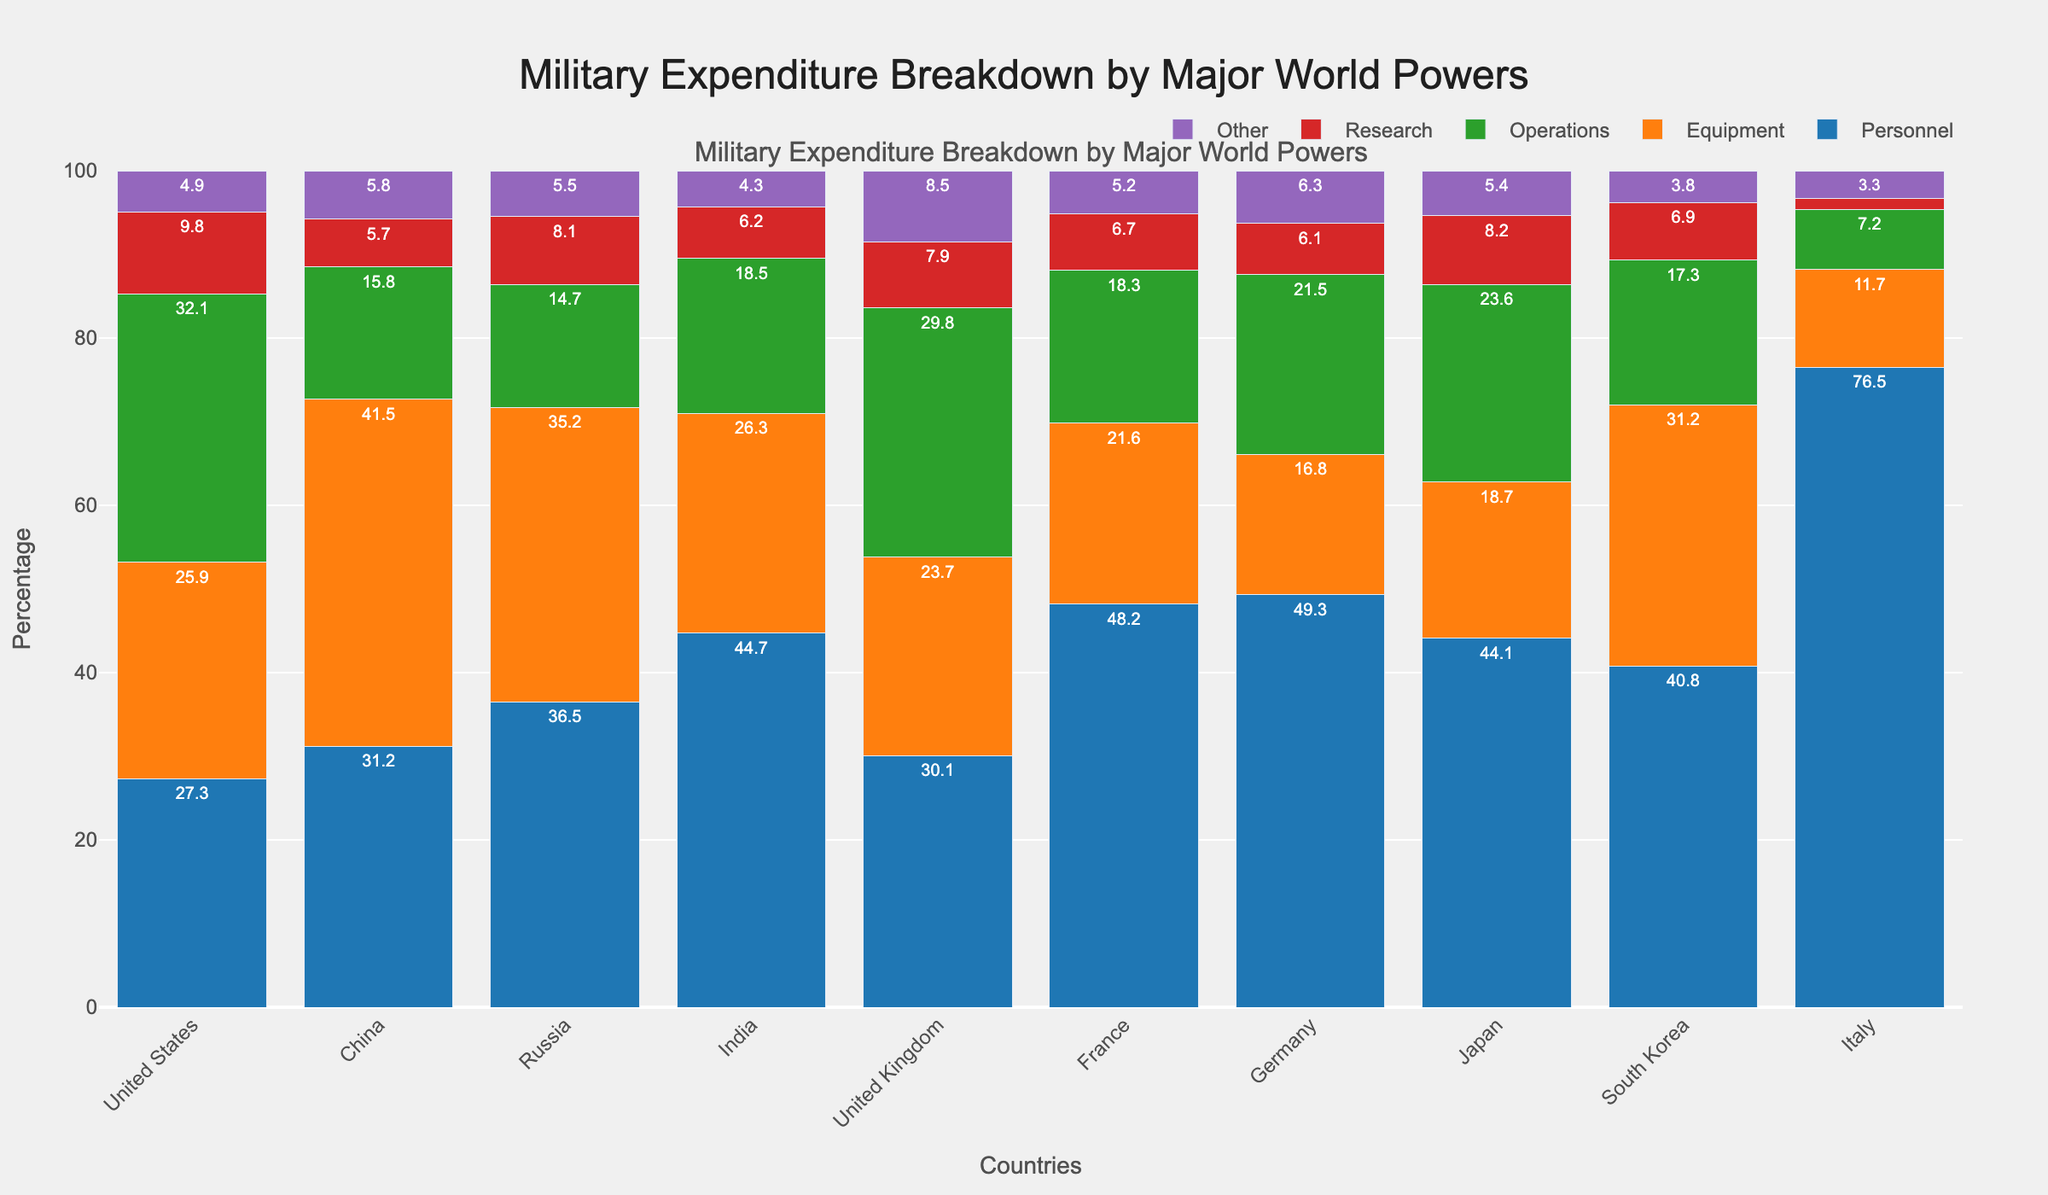What's the country with the highest percentage of military expenditure dedicated to Personnel? Germany has the highest percentage of military expenditure dedicated to Personnel; this can be observed by noting the tallest bar segment for Personnel in the figure.
Answer: Germany Which country spends a higher percentage on Research, the United Kingdom or Japan? By comparing the heights or values of the bar segments for Research of the United Kingdom and Japan, we can see that Japan's segment is slightly taller at 8.2% compared to the United Kingdom's 7.9%.
Answer: Japan What’s the combined percentage of expenditure on Equipment and Operations for China? China’s expenditure on Equipment is 41.5% and on Operations is 15.8%. Adding these two percentages gives 41.5% + 15.8% = 57.3%.
Answer: 57.3% Which country has the smallest percentage of expenditure on Other, and what is that percentage? By comparing the heights of the bar segments for Other across all countries, it is clear that Italy has the smallest segment at 3.3%.
Answer: Italy, 3.3% Is the percentage expenditure on Personnel higher in South Korea or India? By comparing the heights or percentages of the Personnel segment, we see that South Korea has 40.8% and India has 44.7%. Hence, India’s percentage expenditure on Personnel is higher.
Answer: India Which country has the closest percentage expenditure on Equipment to that of France? France's percentage expenditure on Equipment is 21.6%. The country with the closest percentage expenditure on Equipment is Japan, at 18.7%.
Answer: Japan For the United States, are the combined percentages of expenditure on Research and Other greater than on Equipment? The expenditure on Research for the United States is 9.8% and Other is 4.9%, which sums up to 9.8% + 4.9% = 14.7%. This is less than the expenditure on Equipment, which is 25.9%.
Answer: No Which two countries have the highest percentage difference in their expenditure on Operations? To determine this, observe the bar segments for Operations. The largest difference is between the United States (32.1%) and Italy (7.2%), resulting in a difference of 32.1% - 7.2% = 24.9%.
Answer: United States and Italy, 24.9% Which country allocates the highest percentage to Operations? By comparing the heights or values of the bar segments dedicated to Operations, it is evident that the United States allocates the highest percentage at 32.1%.
Answer: United States 